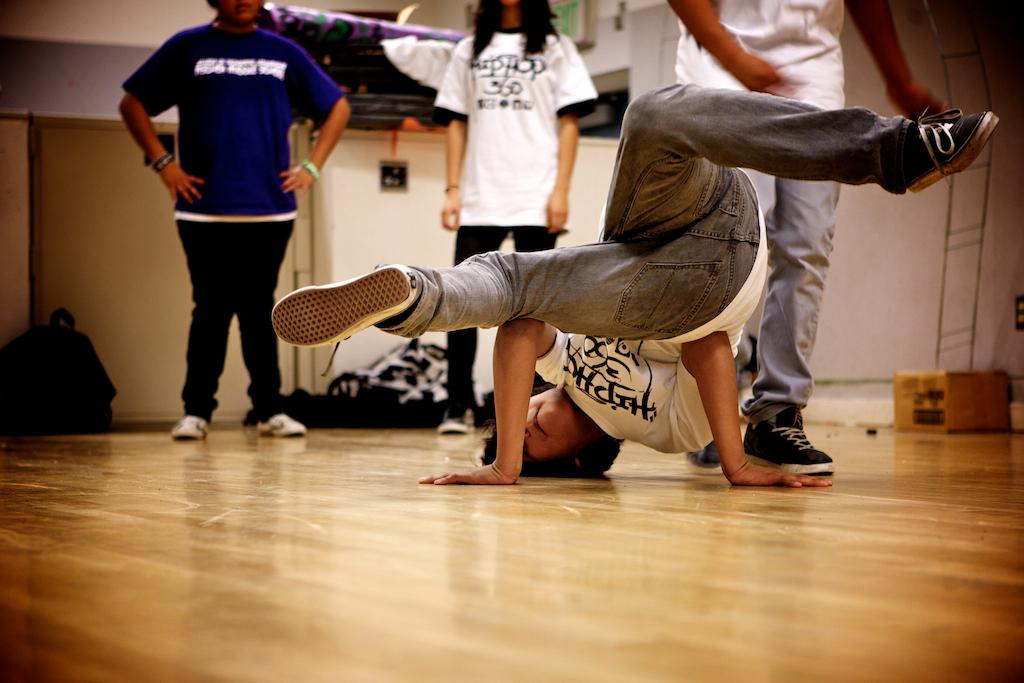What is the primary surface in the image? There is a floor in the image. What is the person in the image doing? A person is dancing in the image. Are there any other people present in the image? Yes, there are other people standing in the image. What can be seen on the right side of the image? There is a box on the right side of the image. What objects are visible in the background of the image? There are bags in the background of the image. What is the surrounding structure in the image? There is a wall in the image. Where is the notebook placed in the image? There is no notebook present in the image. What type of plant can be seen growing near the dancing person? There is no plant visible in the image. 